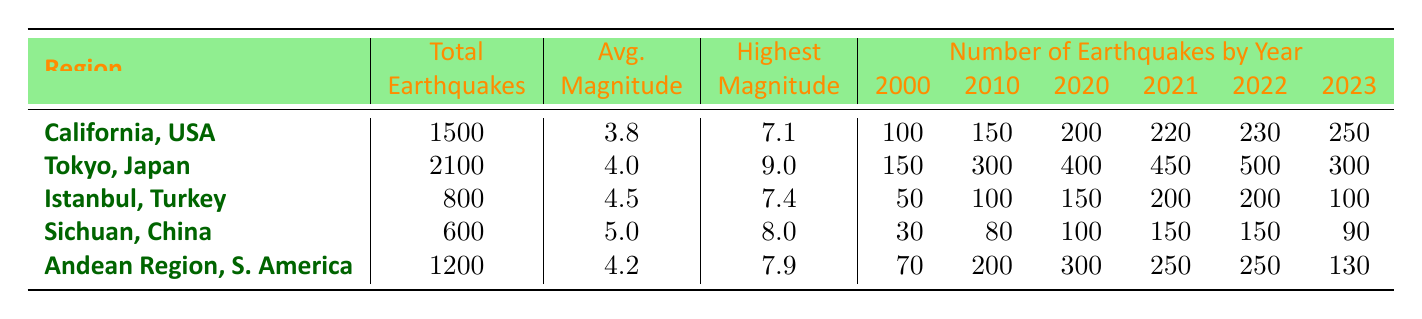What is the total number of earthquakes recorded in Tokyo, Japan? The table lists the total earthquakes for each region. For Tokyo, the value is provided as 2100 under the total earthquakes column.
Answer: 2100 Which region had the highest average magnitude of earthquakes? The average magnitudes for each region are: California - 3.8, Tokyo - 4.0, Istanbul - 4.5, Sichuan - 5.0, Andean Region - 4.2. The highest is Sichuan at 5.0.
Answer: Sichuan, China How many earthquakes were recorded in Istanbul, Turkey in 2022? The table shows that Istanbul had 200 earthquakes in 2022, listed in the corresponding year column.
Answer: 200 What is the difference in total earthquakes between Tokyo, Japan, and Sichuan, China? Total earthquakes in Tokyo is 2100, and for Sichuan it's 600. The difference is calculated as 2100 - 600 = 1500.
Answer: 1500 Did California experience more earthquakes in 2023 compared to 2022? In the table, California had 250 earthquakes in 2023 and 230 in 2022. Since 250 is greater than 230, the answer is yes.
Answer: Yes What was the highest magnitude recorded in the Andean Region of South America? The highest magnitude is specified in the table under the highest magnitude column for the Andean Region, which is listed as 7.9.
Answer: 7.9 If we average the total earthquakes of California, Tokyo, and Istanbul, what is the result? We sum the total earthquakes: California 1500 + Tokyo 2100 + Istanbul 800 = 4400. Then, divide by 3 (number of regions): 4400 / 3 = approximately 1466.67.
Answer: 1466.67 How many earthquakes were recorded in the year 2020 across all regions combined? For 2020, the earthquakes per region are: California 200, Tokyo 400, Istanbul 150, Sichuan 100, Andean Region 300. The total is 200 + 400 + 150 + 100 + 300 = 1150.
Answer: 1150 Which region had the least total number of earthquakes? Based on the total earthquakes in the table, Sichuan has the lowest total with 600 compared to California, Tokyo, Istanbul, and Andean Region.
Answer: Sichuan, China 